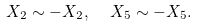<formula> <loc_0><loc_0><loc_500><loc_500>X _ { 2 } \sim - X _ { 2 } , \ \ X _ { 5 } \sim - X _ { 5 } .</formula> 